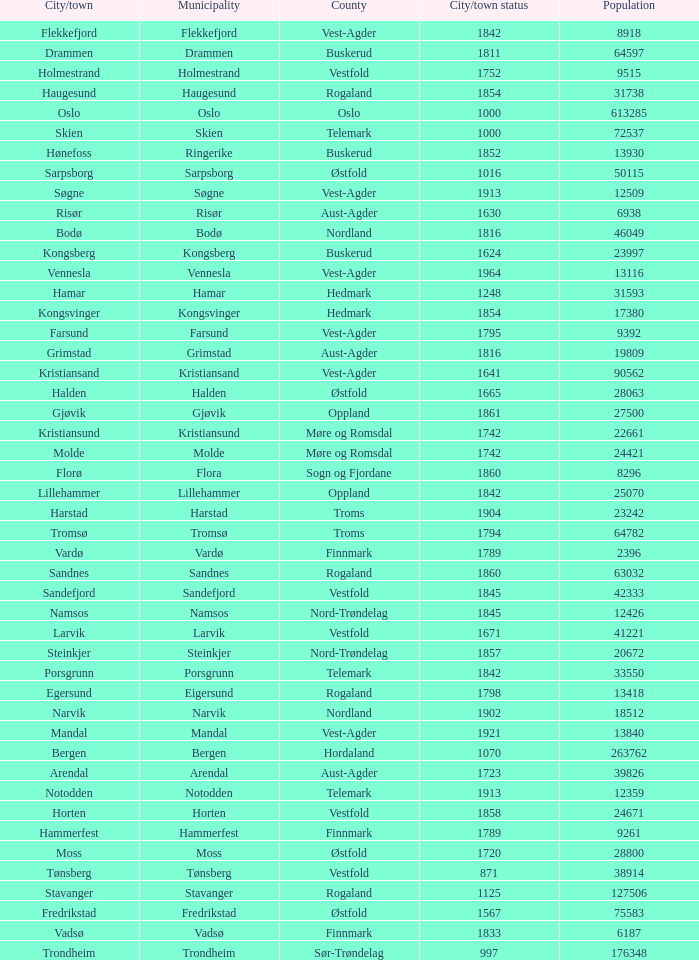What are the cities/towns located in the municipality of Moss? Moss. 